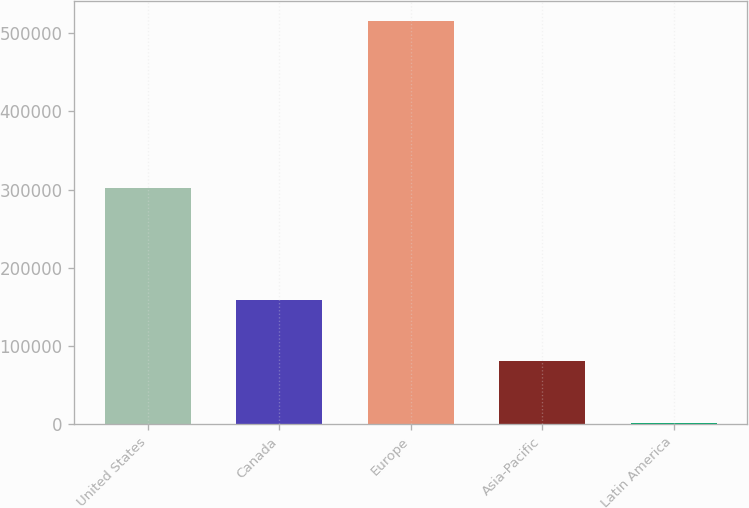Convert chart. <chart><loc_0><loc_0><loc_500><loc_500><bar_chart><fcel>United States<fcel>Canada<fcel>Europe<fcel>Asia-Pacific<fcel>Latin America<nl><fcel>302048<fcel>158978<fcel>516093<fcel>80976<fcel>1345<nl></chart> 